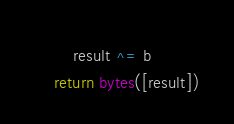<code> <loc_0><loc_0><loc_500><loc_500><_Python_>        result ^= b
    return bytes([result])
</code> 